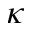Convert formula to latex. <formula><loc_0><loc_0><loc_500><loc_500>\kappa</formula> 